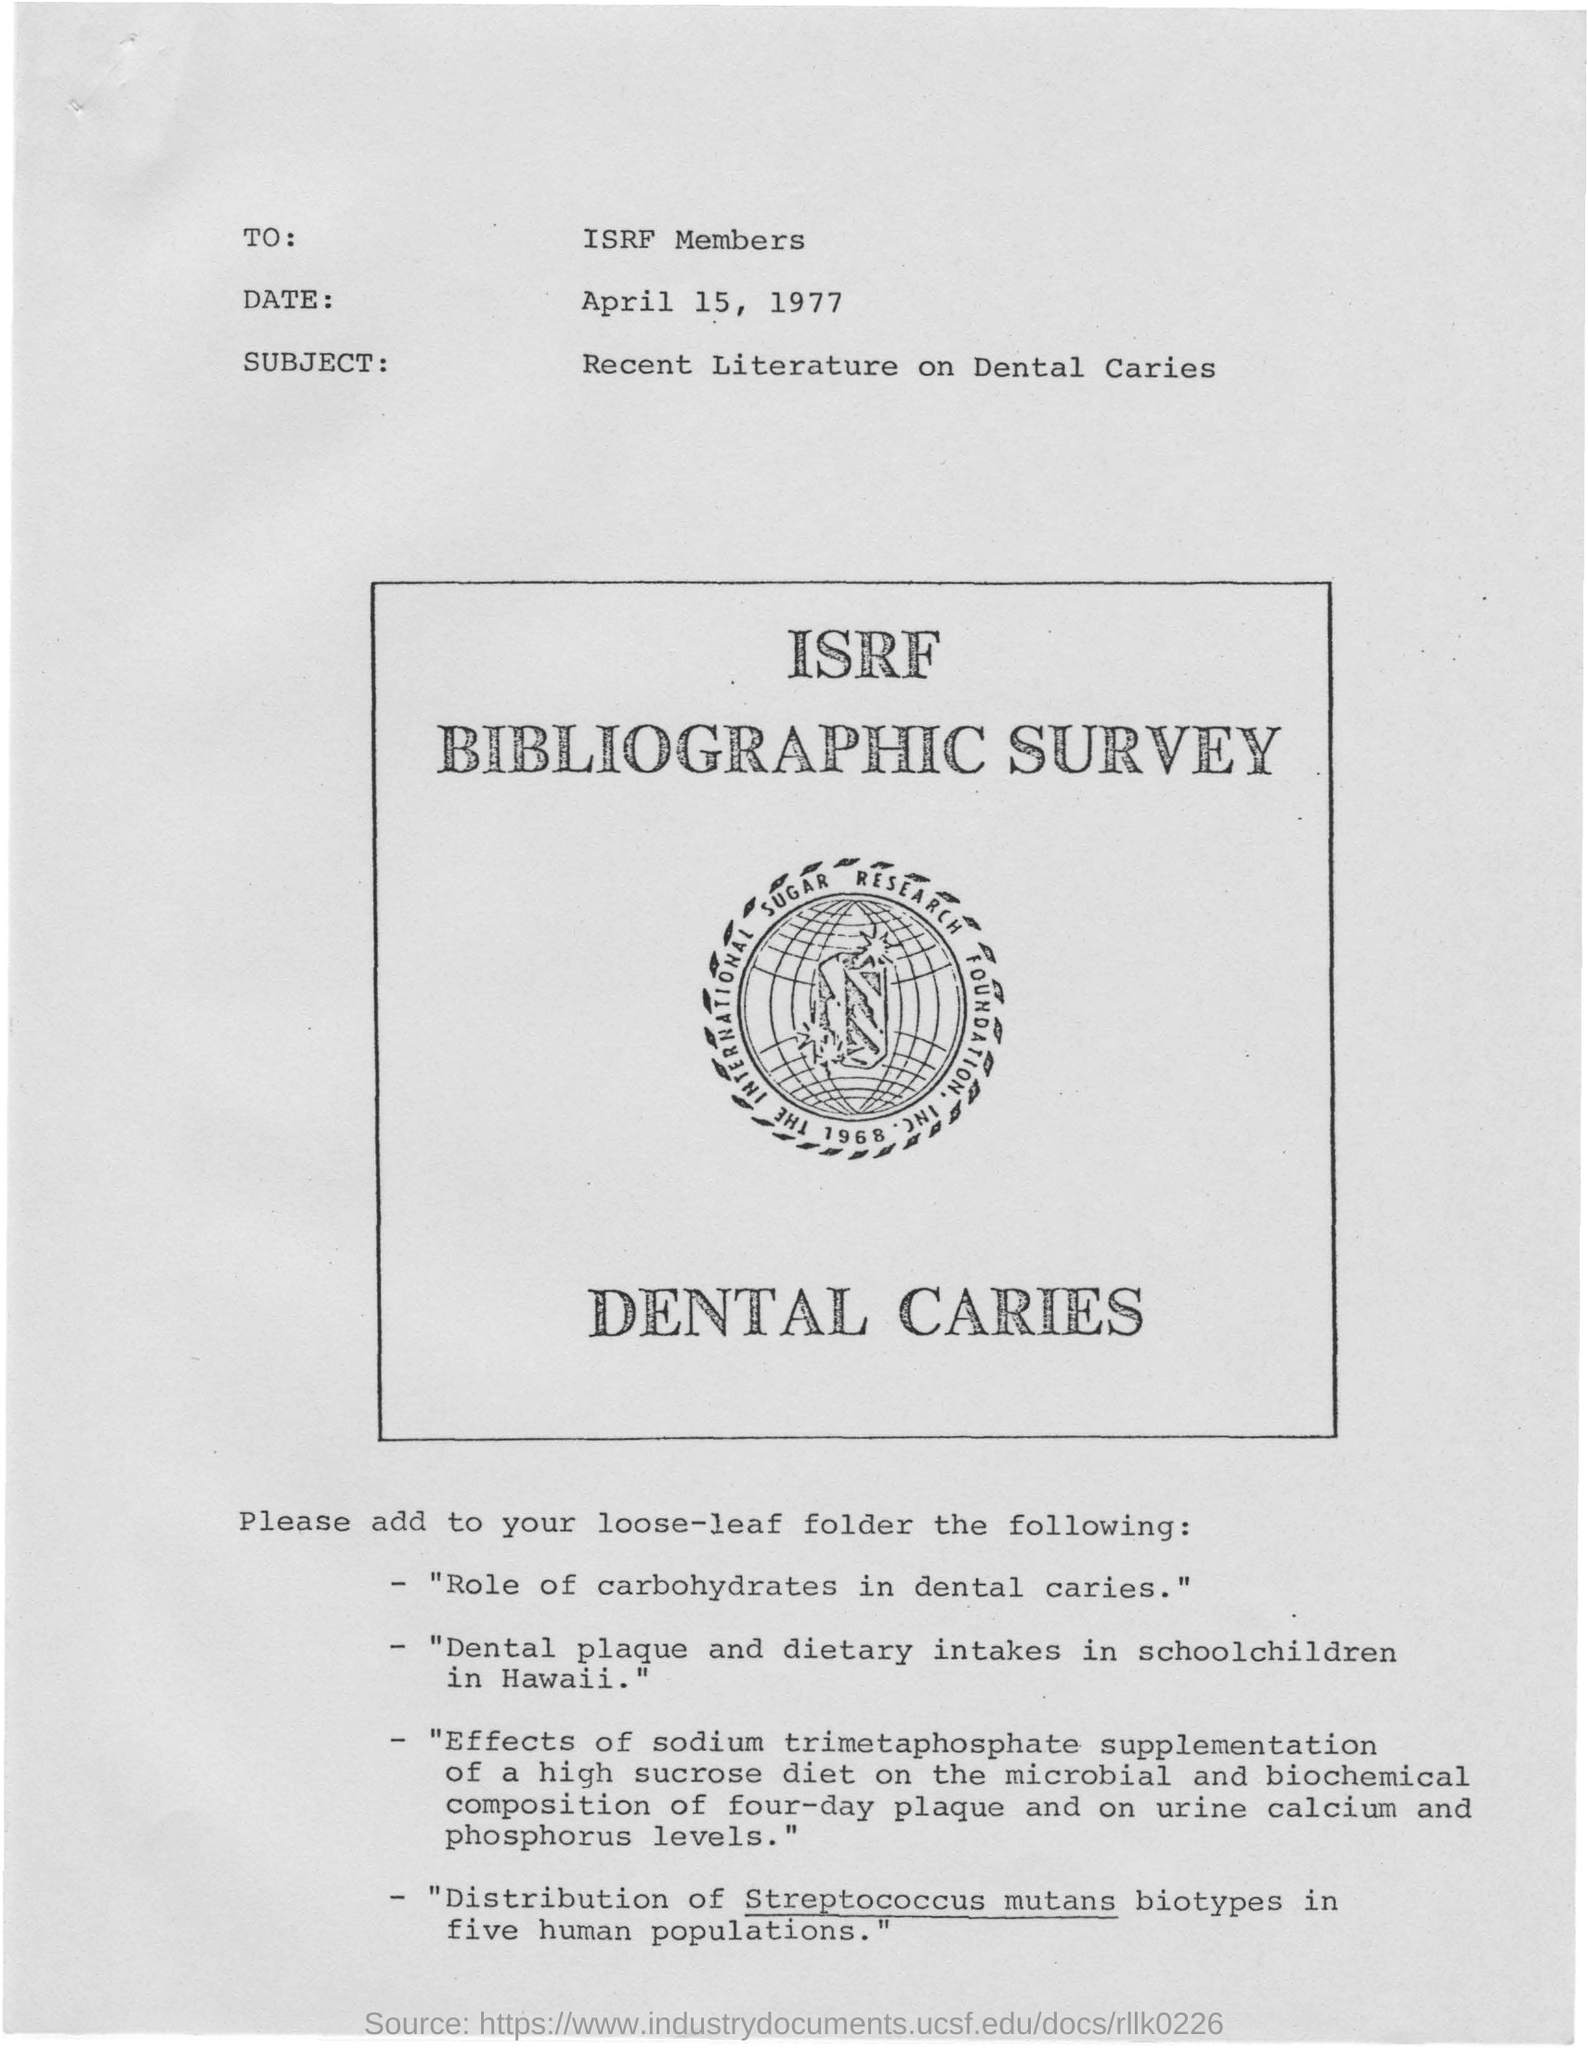To whom is this document addressed?
Your answer should be compact. ISRF Members. What is the date mentioned in this document?
Ensure brevity in your answer.  April 15, 1977. What is the subject of the document?
Offer a very short reply. Recent literature on dental caries. Which biotypes distribution is taken place in five human populations?
Offer a terse response. Streptococcus mutans. 